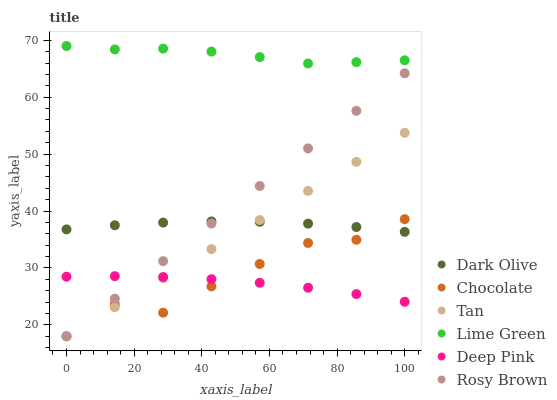Does Deep Pink have the minimum area under the curve?
Answer yes or no. Yes. Does Lime Green have the maximum area under the curve?
Answer yes or no. Yes. Does Dark Olive have the minimum area under the curve?
Answer yes or no. No. Does Dark Olive have the maximum area under the curve?
Answer yes or no. No. Is Tan the smoothest?
Answer yes or no. Yes. Is Chocolate the roughest?
Answer yes or no. Yes. Is Dark Olive the smoothest?
Answer yes or no. No. Is Dark Olive the roughest?
Answer yes or no. No. Does Rosy Brown have the lowest value?
Answer yes or no. Yes. Does Dark Olive have the lowest value?
Answer yes or no. No. Does Lime Green have the highest value?
Answer yes or no. Yes. Does Dark Olive have the highest value?
Answer yes or no. No. Is Chocolate less than Lime Green?
Answer yes or no. Yes. Is Dark Olive greater than Deep Pink?
Answer yes or no. Yes. Does Dark Olive intersect Chocolate?
Answer yes or no. Yes. Is Dark Olive less than Chocolate?
Answer yes or no. No. Is Dark Olive greater than Chocolate?
Answer yes or no. No. Does Chocolate intersect Lime Green?
Answer yes or no. No. 